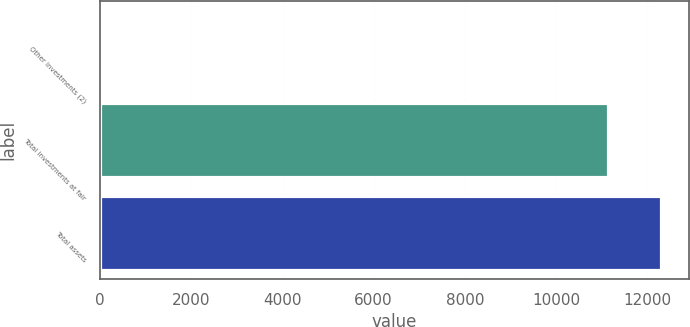Convert chart. <chart><loc_0><loc_0><loc_500><loc_500><bar_chart><fcel>Other investments (2)<fcel>Total investments at fair<fcel>Total assets<nl><fcel>50<fcel>11143<fcel>12303.6<nl></chart> 